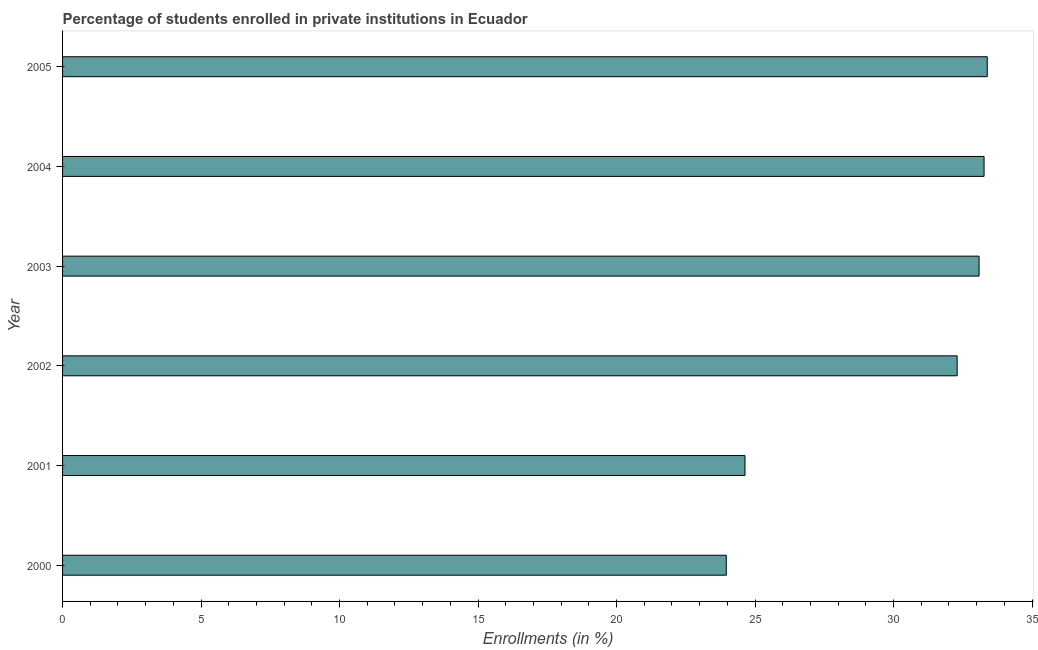Does the graph contain any zero values?
Your answer should be compact. No. Does the graph contain grids?
Your answer should be very brief. No. What is the title of the graph?
Your answer should be very brief. Percentage of students enrolled in private institutions in Ecuador. What is the label or title of the X-axis?
Make the answer very short. Enrollments (in %). What is the enrollments in private institutions in 2000?
Give a very brief answer. 23.96. Across all years, what is the maximum enrollments in private institutions?
Make the answer very short. 33.38. Across all years, what is the minimum enrollments in private institutions?
Your answer should be compact. 23.96. In which year was the enrollments in private institutions maximum?
Offer a very short reply. 2005. What is the sum of the enrollments in private institutions?
Offer a terse response. 180.63. What is the difference between the enrollments in private institutions in 2001 and 2005?
Keep it short and to the point. -8.75. What is the average enrollments in private institutions per year?
Make the answer very short. 30.11. What is the median enrollments in private institutions?
Your response must be concise. 32.69. In how many years, is the enrollments in private institutions greater than 11 %?
Give a very brief answer. 6. What is the ratio of the enrollments in private institutions in 2003 to that in 2004?
Offer a very short reply. 0.99. Is the difference between the enrollments in private institutions in 2004 and 2005 greater than the difference between any two years?
Provide a succinct answer. No. What is the difference between the highest and the second highest enrollments in private institutions?
Keep it short and to the point. 0.12. What is the difference between the highest and the lowest enrollments in private institutions?
Offer a very short reply. 9.42. In how many years, is the enrollments in private institutions greater than the average enrollments in private institutions taken over all years?
Your response must be concise. 4. How many bars are there?
Your response must be concise. 6. How many years are there in the graph?
Ensure brevity in your answer.  6. What is the Enrollments (in %) of 2000?
Provide a succinct answer. 23.96. What is the Enrollments (in %) in 2001?
Ensure brevity in your answer.  24.64. What is the Enrollments (in %) of 2002?
Provide a short and direct response. 32.3. What is the Enrollments (in %) in 2003?
Your response must be concise. 33.09. What is the Enrollments (in %) of 2004?
Provide a short and direct response. 33.27. What is the Enrollments (in %) of 2005?
Make the answer very short. 33.38. What is the difference between the Enrollments (in %) in 2000 and 2001?
Provide a succinct answer. -0.68. What is the difference between the Enrollments (in %) in 2000 and 2002?
Keep it short and to the point. -8.33. What is the difference between the Enrollments (in %) in 2000 and 2003?
Your answer should be compact. -9.13. What is the difference between the Enrollments (in %) in 2000 and 2004?
Your response must be concise. -9.31. What is the difference between the Enrollments (in %) in 2000 and 2005?
Provide a short and direct response. -9.42. What is the difference between the Enrollments (in %) in 2001 and 2002?
Your answer should be very brief. -7.66. What is the difference between the Enrollments (in %) in 2001 and 2003?
Offer a very short reply. -8.45. What is the difference between the Enrollments (in %) in 2001 and 2004?
Keep it short and to the point. -8.63. What is the difference between the Enrollments (in %) in 2001 and 2005?
Your answer should be very brief. -8.75. What is the difference between the Enrollments (in %) in 2002 and 2003?
Your response must be concise. -0.79. What is the difference between the Enrollments (in %) in 2002 and 2004?
Ensure brevity in your answer.  -0.97. What is the difference between the Enrollments (in %) in 2002 and 2005?
Ensure brevity in your answer.  -1.09. What is the difference between the Enrollments (in %) in 2003 and 2004?
Provide a short and direct response. -0.18. What is the difference between the Enrollments (in %) in 2003 and 2005?
Offer a terse response. -0.3. What is the difference between the Enrollments (in %) in 2004 and 2005?
Your answer should be compact. -0.12. What is the ratio of the Enrollments (in %) in 2000 to that in 2002?
Your response must be concise. 0.74. What is the ratio of the Enrollments (in %) in 2000 to that in 2003?
Provide a succinct answer. 0.72. What is the ratio of the Enrollments (in %) in 2000 to that in 2004?
Make the answer very short. 0.72. What is the ratio of the Enrollments (in %) in 2000 to that in 2005?
Offer a very short reply. 0.72. What is the ratio of the Enrollments (in %) in 2001 to that in 2002?
Your answer should be very brief. 0.76. What is the ratio of the Enrollments (in %) in 2001 to that in 2003?
Your answer should be very brief. 0.74. What is the ratio of the Enrollments (in %) in 2001 to that in 2004?
Provide a succinct answer. 0.74. What is the ratio of the Enrollments (in %) in 2001 to that in 2005?
Keep it short and to the point. 0.74. What is the ratio of the Enrollments (in %) in 2002 to that in 2003?
Offer a very short reply. 0.98. What is the ratio of the Enrollments (in %) in 2002 to that in 2005?
Provide a short and direct response. 0.97. What is the ratio of the Enrollments (in %) in 2003 to that in 2004?
Make the answer very short. 0.99. What is the ratio of the Enrollments (in %) in 2003 to that in 2005?
Offer a very short reply. 0.99. 